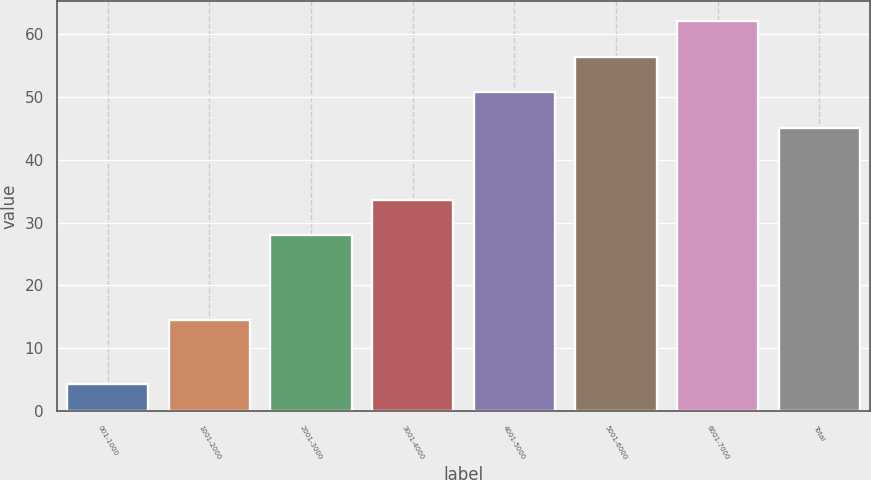Convert chart to OTSL. <chart><loc_0><loc_0><loc_500><loc_500><bar_chart><fcel>001-1000<fcel>1001-2000<fcel>2001-3000<fcel>3001-4000<fcel>4001-5000<fcel>5001-6000<fcel>6001-7000<fcel>Total<nl><fcel>4.31<fcel>14.55<fcel>27.97<fcel>33.66<fcel>50.68<fcel>56.37<fcel>62.06<fcel>44.99<nl></chart> 